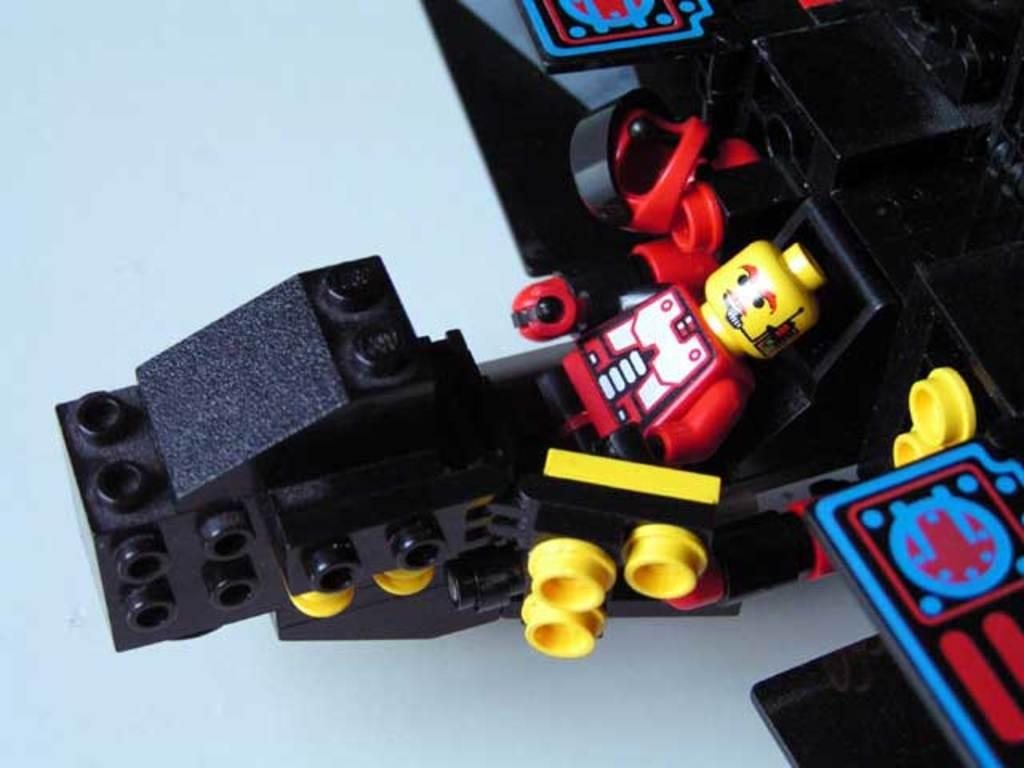What type of objects are present in the image? There are building blocks and toys in the image. Can you describe any other objects in the image? Yes, there are other objects in the image as well. What is the surface on which the objects are placed? There is a floor at the bottom of the image. What are the friends protesting about in the image? There are no friends or protest present in the image; it features building blocks, toys, and other objects on a floor. 